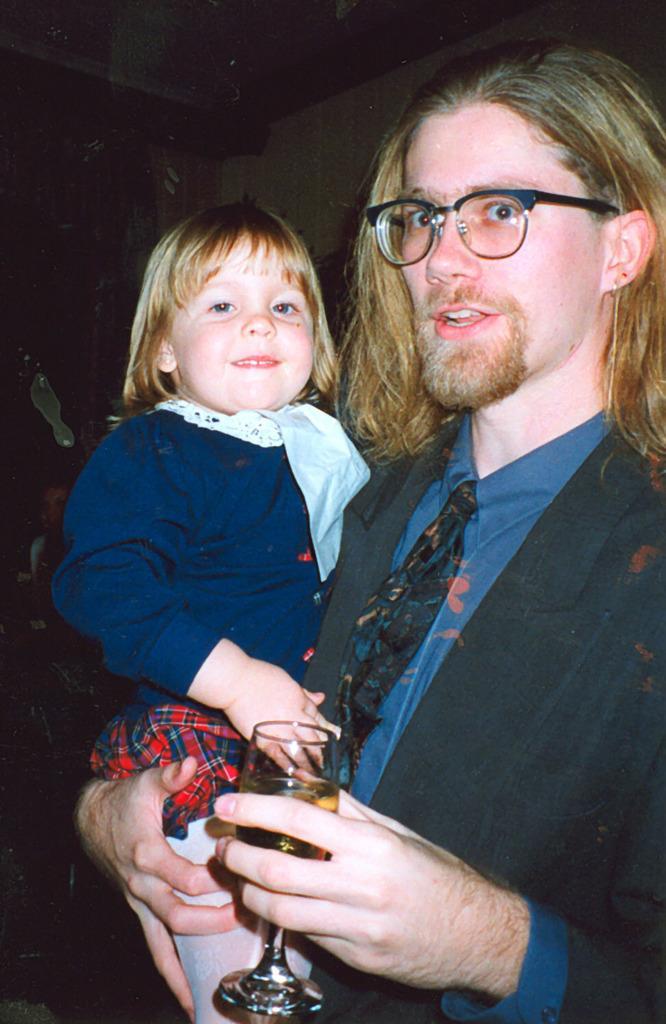How would you summarize this image in a sentence or two? Here this man is holding a baby and glass. He is wearing a blue color suit and tie. He is wearing a spectacle. In the background, this is the wall. 